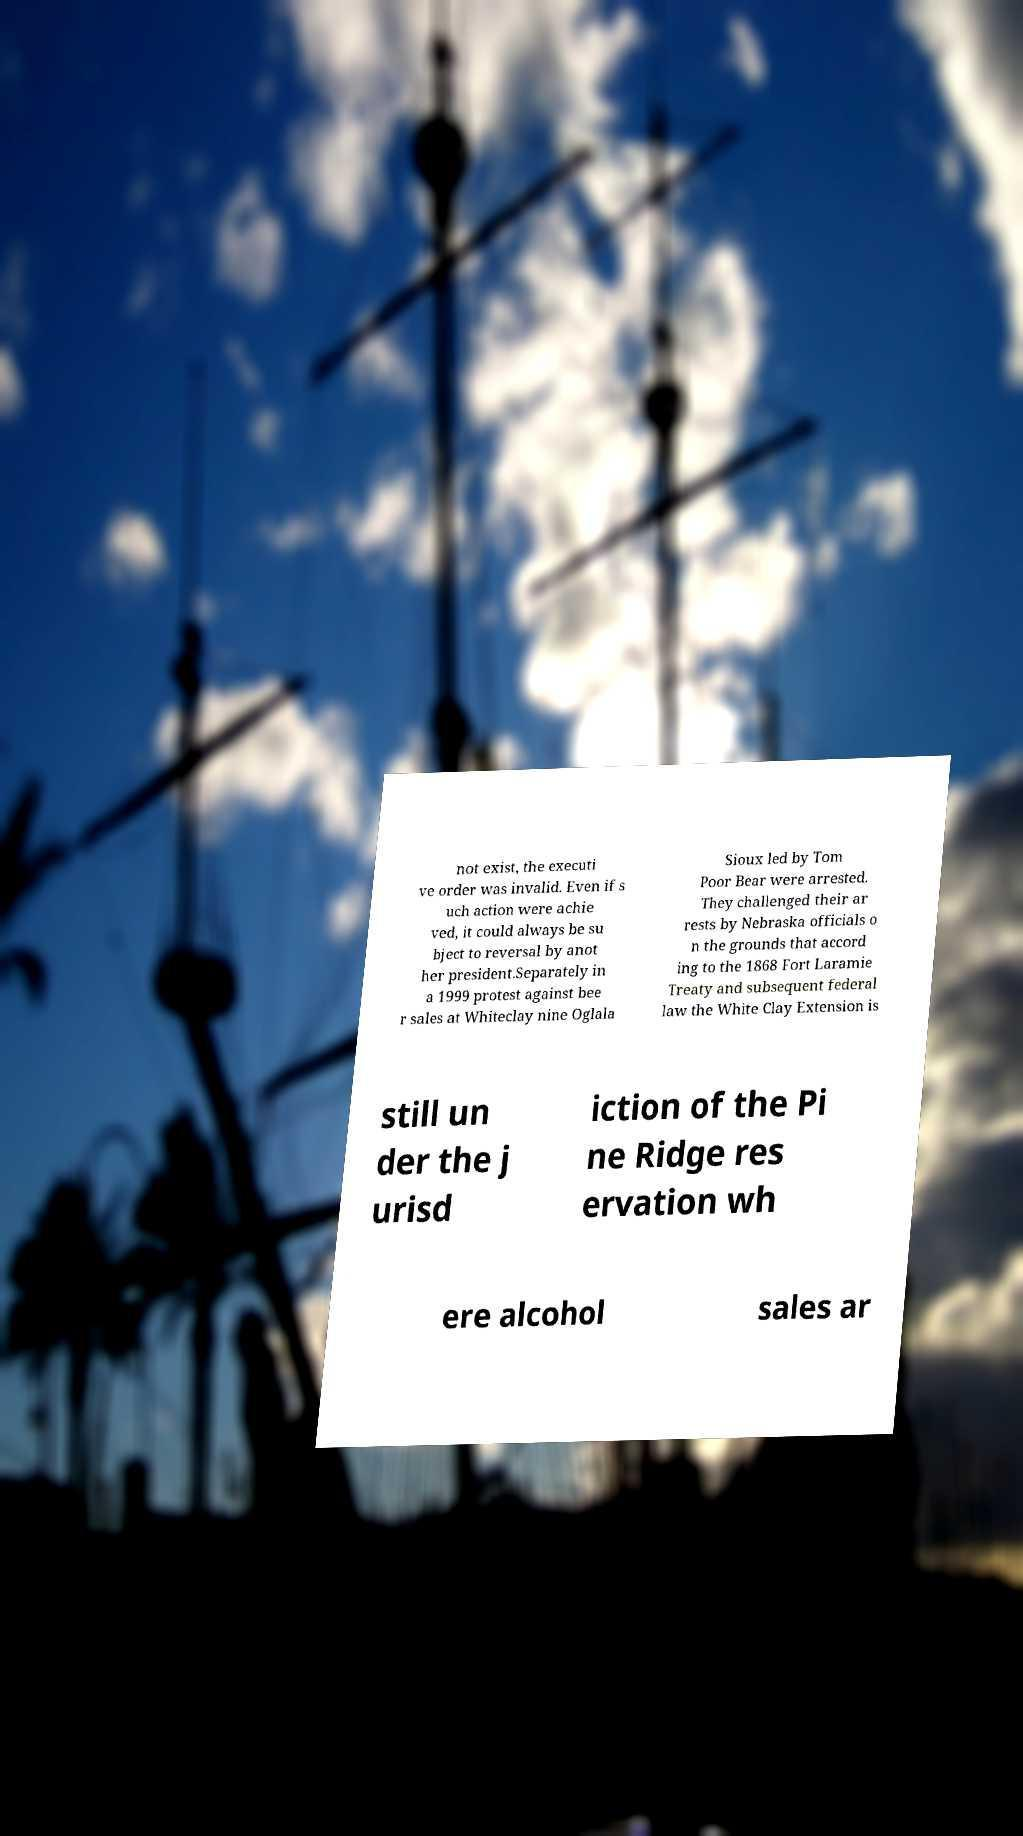Could you extract and type out the text from this image? not exist, the executi ve order was invalid. Even if s uch action were achie ved, it could always be su bject to reversal by anot her president.Separately in a 1999 protest against bee r sales at Whiteclay nine Oglala Sioux led by Tom Poor Bear were arrested. They challenged their ar rests by Nebraska officials o n the grounds that accord ing to the 1868 Fort Laramie Treaty and subsequent federal law the White Clay Extension is still un der the j urisd iction of the Pi ne Ridge res ervation wh ere alcohol sales ar 